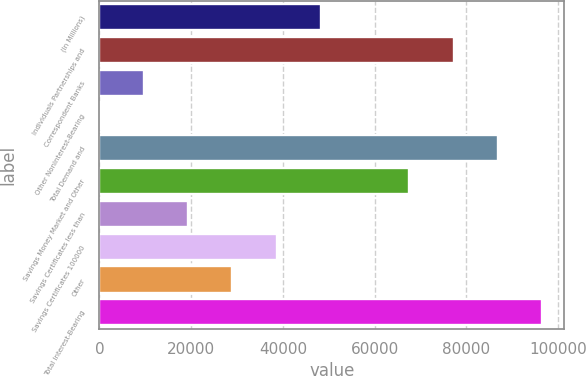<chart> <loc_0><loc_0><loc_500><loc_500><bar_chart><fcel>(In Millions)<fcel>Individuals Partnerships and<fcel>Correspondent Banks<fcel>Other Noninterest-Bearing<fcel>Total Demand and<fcel>Savings Money Market and Other<fcel>Savings Certificates less than<fcel>Savings Certificates 100000<fcel>Other<fcel>Total Interest-Bearing<nl><fcel>48253.1<fcel>77204.1<fcel>9651.74<fcel>1.4<fcel>86854.5<fcel>67553.8<fcel>19302.1<fcel>38602.8<fcel>28952.4<fcel>96504.8<nl></chart> 